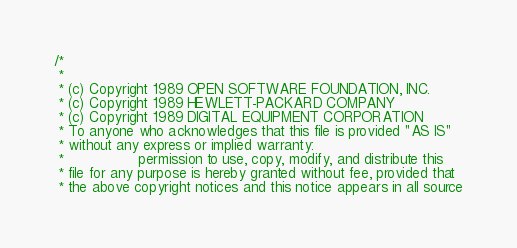Convert code to text. <code><loc_0><loc_0><loc_500><loc_500><_C_>/*
 * 
 * (c) Copyright 1989 OPEN SOFTWARE FOUNDATION, INC.
 * (c) Copyright 1989 HEWLETT-PACKARD COMPANY
 * (c) Copyright 1989 DIGITAL EQUIPMENT CORPORATION
 * To anyone who acknowledges that this file is provided "AS IS"
 * without any express or implied warranty:
 *                 permission to use, copy, modify, and distribute this
 * file for any purpose is hereby granted without fee, provided that
 * the above copyright notices and this notice appears in all source</code> 